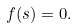<formula> <loc_0><loc_0><loc_500><loc_500>f ( s ) = 0 .</formula> 